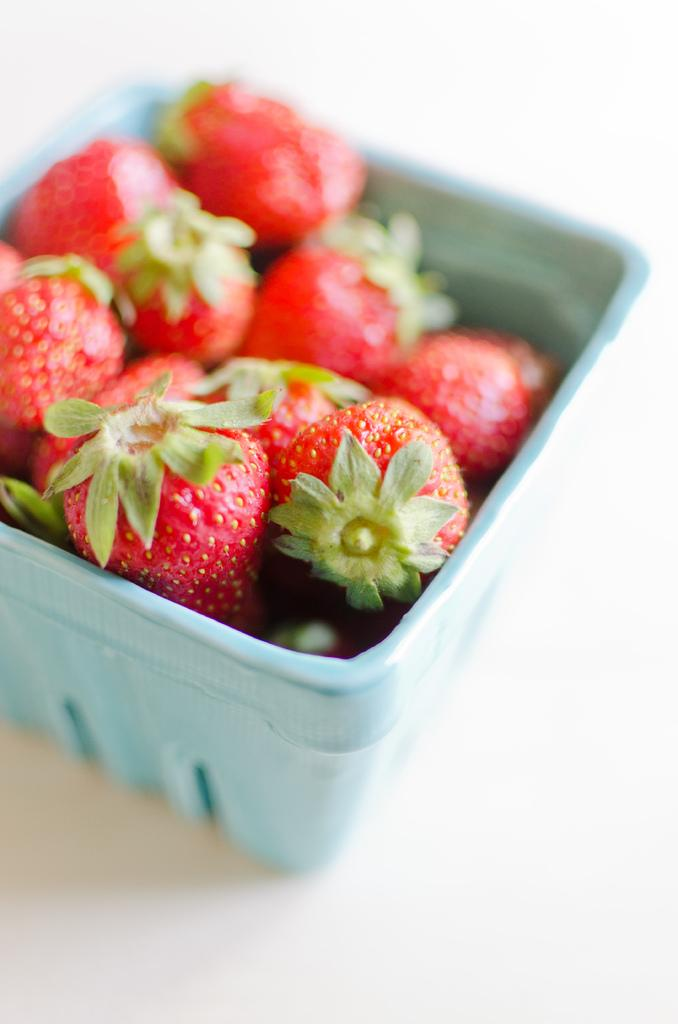What type of fruit can be seen in the image? There are strawberries in the image. How are the strawberries contained in the image? The strawberries are in a box. Where is the box with strawberries located? The box is placed on a table. What part of the mailbox is visible in the image? There is no mailbox present in the image. What angle is the strawberry positioned at in the image? The angle of the strawberries cannot be determined from the image, as they are contained within a box. 